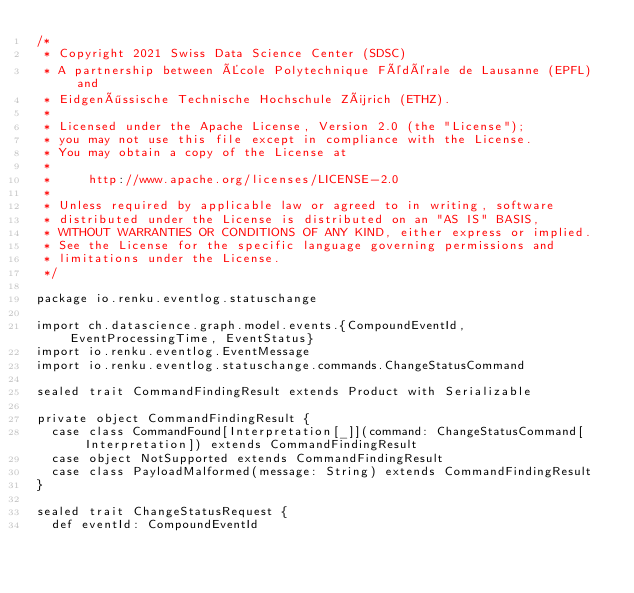Convert code to text. <code><loc_0><loc_0><loc_500><loc_500><_Scala_>/*
 * Copyright 2021 Swiss Data Science Center (SDSC)
 * A partnership between École Polytechnique Fédérale de Lausanne (EPFL) and
 * Eidgenössische Technische Hochschule Zürich (ETHZ).
 *
 * Licensed under the Apache License, Version 2.0 (the "License");
 * you may not use this file except in compliance with the License.
 * You may obtain a copy of the License at
 *
 *     http://www.apache.org/licenses/LICENSE-2.0
 *
 * Unless required by applicable law or agreed to in writing, software
 * distributed under the License is distributed on an "AS IS" BASIS,
 * WITHOUT WARRANTIES OR CONDITIONS OF ANY KIND, either express or implied.
 * See the License for the specific language governing permissions and
 * limitations under the License.
 */

package io.renku.eventlog.statuschange

import ch.datascience.graph.model.events.{CompoundEventId, EventProcessingTime, EventStatus}
import io.renku.eventlog.EventMessage
import io.renku.eventlog.statuschange.commands.ChangeStatusCommand

sealed trait CommandFindingResult extends Product with Serializable

private object CommandFindingResult {
  case class CommandFound[Interpretation[_]](command: ChangeStatusCommand[Interpretation]) extends CommandFindingResult
  case object NotSupported extends CommandFindingResult
  case class PayloadMalformed(message: String) extends CommandFindingResult
}

sealed trait ChangeStatusRequest {
  def eventId: CompoundEventId</code> 